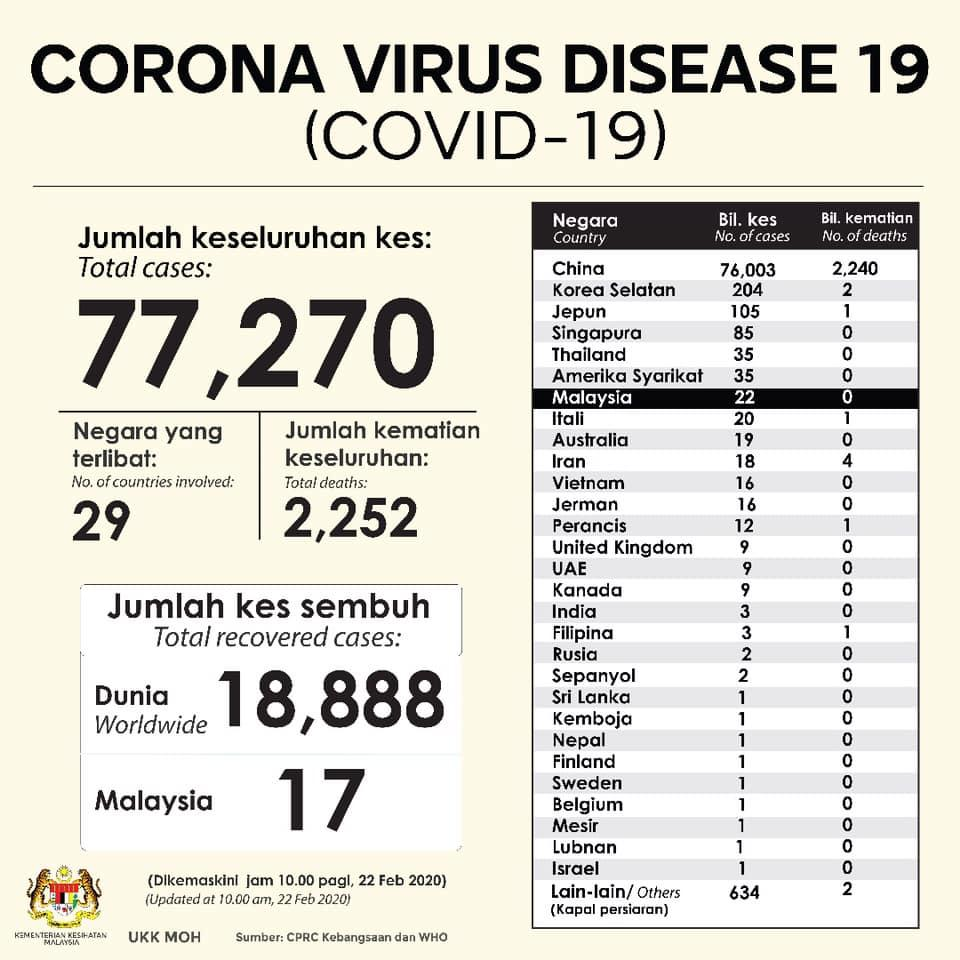Specify some key components in this picture. The number of cases and number of deaths in Thailand are 35. In how many countries are there only one case? The number of cases and number of deaths in Israel is 1. The number of cases and deaths in Iran are 14. 